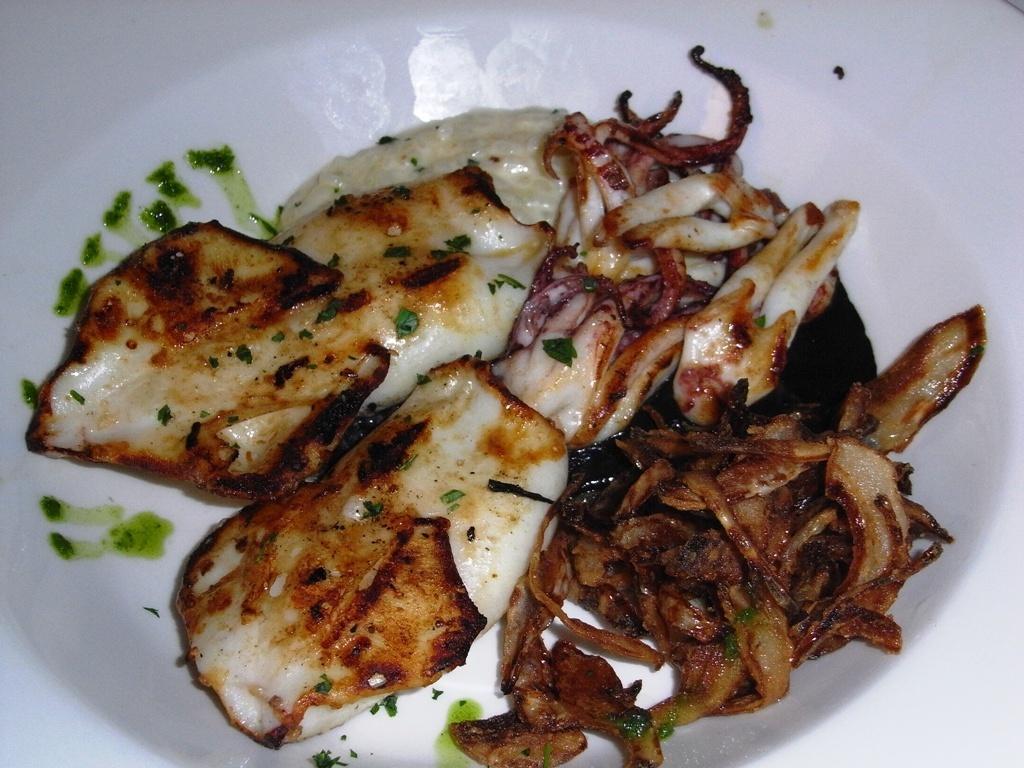Could you give a brief overview of what you see in this image? In this picture I can see a white color thing on which there is food, which is of white, cream, green and brown color. 